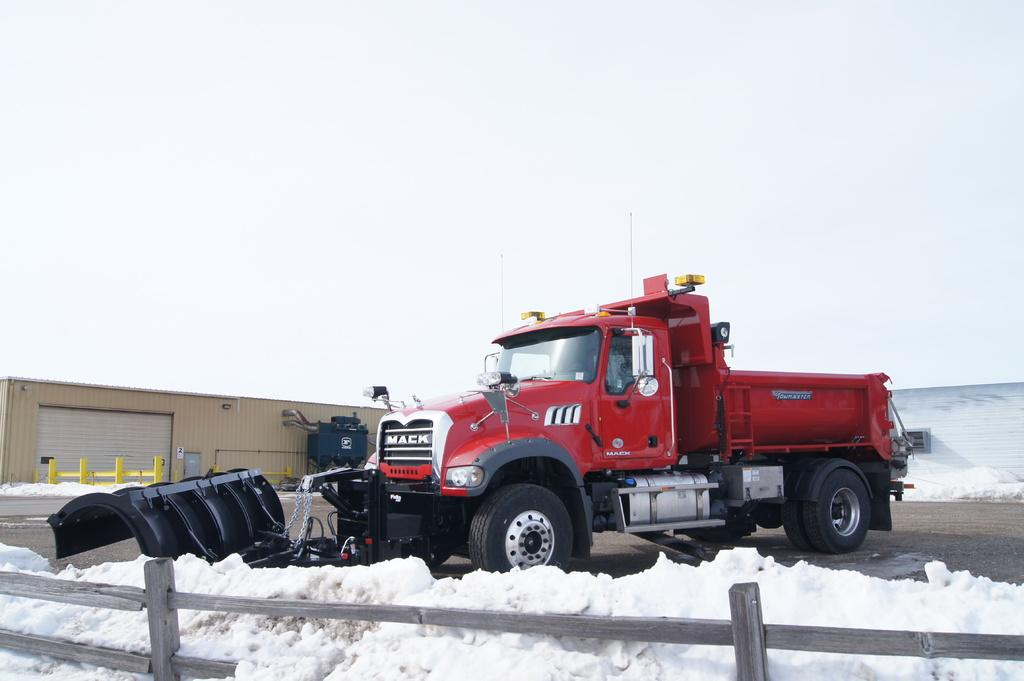What is the main subject in the image? There is a vehicle in the image. What else can be seen in the image besides the vehicle? There is a fence and snow visible in the image. Can you describe the fence in the image? The fence is a distinct feature in the image, but no further details are provided. What other objects are present in the image? There are other objects present in the image, but their specific nature is not mentioned in the provided facts. Can you tell me what the writer is doing in the image? There is no writer present in the image. Is there a ghost visible in the image? There is no ghost visible in the image. 